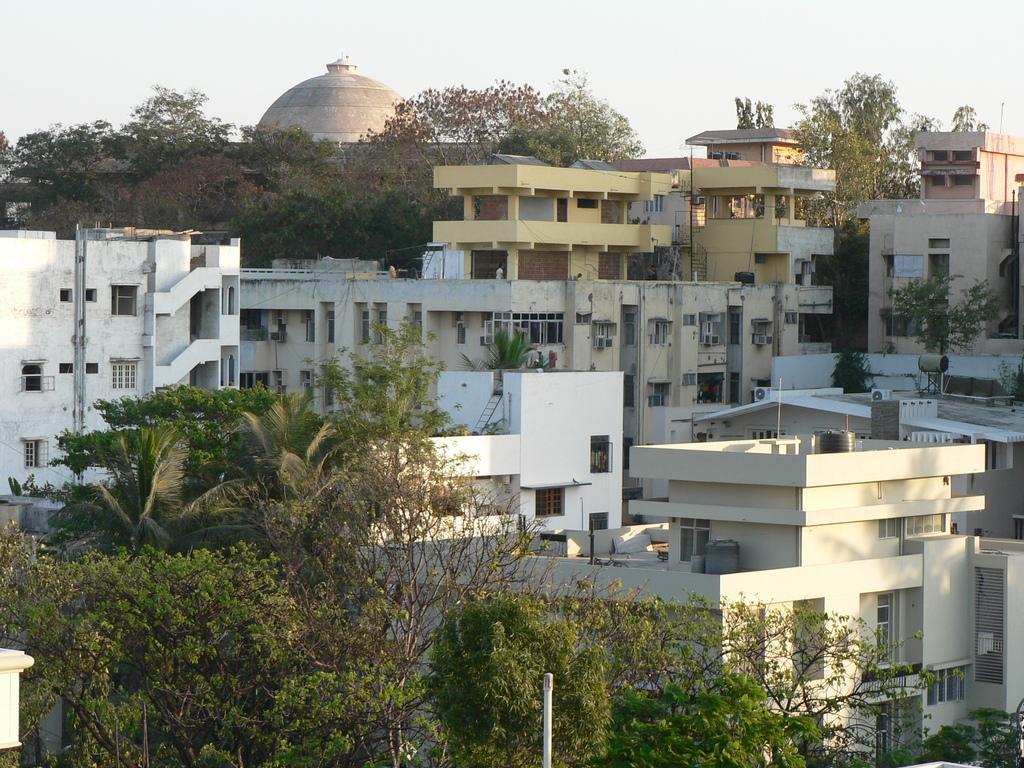In one or two sentences, can you explain what this image depicts? In the image we can see some trees, poles and buildings. At the top of the image there is sky. 